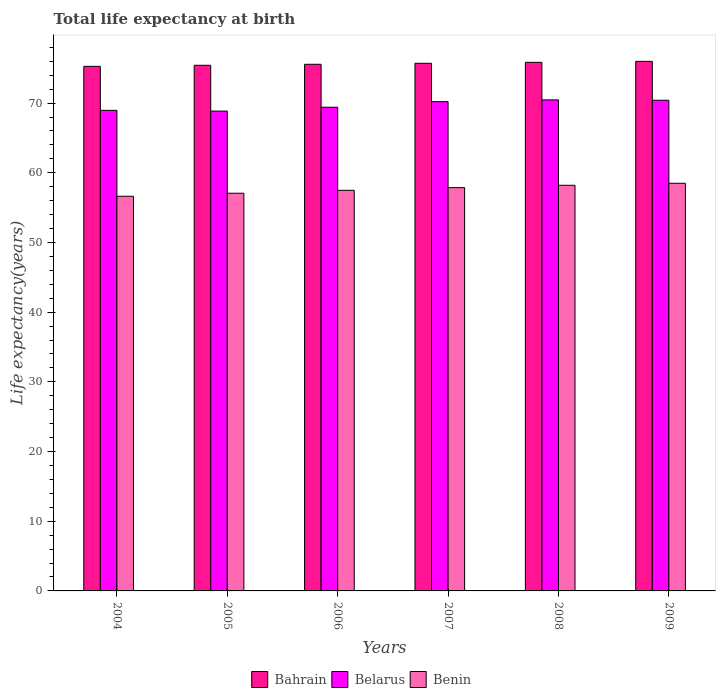How many groups of bars are there?
Your response must be concise. 6. Are the number of bars per tick equal to the number of legend labels?
Your answer should be very brief. Yes. How many bars are there on the 4th tick from the left?
Ensure brevity in your answer.  3. How many bars are there on the 3rd tick from the right?
Ensure brevity in your answer.  3. What is the life expectancy at birth in in Belarus in 2004?
Make the answer very short. 68.96. Across all years, what is the maximum life expectancy at birth in in Benin?
Provide a short and direct response. 58.49. Across all years, what is the minimum life expectancy at birth in in Benin?
Offer a very short reply. 56.63. In which year was the life expectancy at birth in in Benin maximum?
Your response must be concise. 2009. In which year was the life expectancy at birth in in Bahrain minimum?
Offer a terse response. 2004. What is the total life expectancy at birth in in Bahrain in the graph?
Ensure brevity in your answer.  453.8. What is the difference between the life expectancy at birth in in Bahrain in 2008 and that in 2009?
Provide a succinct answer. -0.14. What is the difference between the life expectancy at birth in in Belarus in 2007 and the life expectancy at birth in in Benin in 2009?
Ensure brevity in your answer.  11.71. What is the average life expectancy at birth in in Benin per year?
Offer a very short reply. 57.62. In the year 2005, what is the difference between the life expectancy at birth in in Belarus and life expectancy at birth in in Benin?
Your response must be concise. 11.79. In how many years, is the life expectancy at birth in in Benin greater than 2 years?
Offer a very short reply. 6. What is the ratio of the life expectancy at birth in in Bahrain in 2004 to that in 2007?
Ensure brevity in your answer.  0.99. Is the life expectancy at birth in in Bahrain in 2007 less than that in 2008?
Your response must be concise. Yes. What is the difference between the highest and the second highest life expectancy at birth in in Bahrain?
Keep it short and to the point. 0.14. What is the difference between the highest and the lowest life expectancy at birth in in Benin?
Provide a short and direct response. 1.86. In how many years, is the life expectancy at birth in in Benin greater than the average life expectancy at birth in in Benin taken over all years?
Ensure brevity in your answer.  3. What does the 3rd bar from the left in 2004 represents?
Ensure brevity in your answer.  Benin. What does the 1st bar from the right in 2008 represents?
Offer a terse response. Benin. Does the graph contain grids?
Make the answer very short. No. Where does the legend appear in the graph?
Keep it short and to the point. Bottom center. How many legend labels are there?
Make the answer very short. 3. What is the title of the graph?
Offer a very short reply. Total life expectancy at birth. What is the label or title of the Y-axis?
Your response must be concise. Life expectancy(years). What is the Life expectancy(years) of Bahrain in 2004?
Ensure brevity in your answer.  75.27. What is the Life expectancy(years) of Belarus in 2004?
Provide a succinct answer. 68.96. What is the Life expectancy(years) in Benin in 2004?
Your answer should be very brief. 56.63. What is the Life expectancy(years) in Bahrain in 2005?
Keep it short and to the point. 75.42. What is the Life expectancy(years) of Belarus in 2005?
Keep it short and to the point. 68.85. What is the Life expectancy(years) of Benin in 2005?
Provide a short and direct response. 57.07. What is the Life expectancy(years) of Bahrain in 2006?
Provide a short and direct response. 75.57. What is the Life expectancy(years) in Belarus in 2006?
Offer a very short reply. 69.4. What is the Life expectancy(years) in Benin in 2006?
Provide a short and direct response. 57.48. What is the Life expectancy(years) of Bahrain in 2007?
Your response must be concise. 75.71. What is the Life expectancy(years) of Belarus in 2007?
Your answer should be compact. 70.2. What is the Life expectancy(years) in Benin in 2007?
Your answer should be compact. 57.87. What is the Life expectancy(years) in Bahrain in 2008?
Your answer should be compact. 75.85. What is the Life expectancy(years) of Belarus in 2008?
Provide a succinct answer. 70.46. What is the Life expectancy(years) of Benin in 2008?
Offer a very short reply. 58.2. What is the Life expectancy(years) of Bahrain in 2009?
Provide a short and direct response. 75.99. What is the Life expectancy(years) in Belarus in 2009?
Your answer should be very brief. 70.41. What is the Life expectancy(years) in Benin in 2009?
Your answer should be very brief. 58.49. Across all years, what is the maximum Life expectancy(years) of Bahrain?
Ensure brevity in your answer.  75.99. Across all years, what is the maximum Life expectancy(years) of Belarus?
Give a very brief answer. 70.46. Across all years, what is the maximum Life expectancy(years) in Benin?
Give a very brief answer. 58.49. Across all years, what is the minimum Life expectancy(years) in Bahrain?
Keep it short and to the point. 75.27. Across all years, what is the minimum Life expectancy(years) in Belarus?
Your answer should be very brief. 68.85. Across all years, what is the minimum Life expectancy(years) in Benin?
Your response must be concise. 56.63. What is the total Life expectancy(years) of Bahrain in the graph?
Your answer should be compact. 453.8. What is the total Life expectancy(years) in Belarus in the graph?
Offer a terse response. 418.28. What is the total Life expectancy(years) in Benin in the graph?
Offer a terse response. 345.75. What is the difference between the Life expectancy(years) of Bahrain in 2004 and that in 2005?
Your answer should be compact. -0.15. What is the difference between the Life expectancy(years) of Belarus in 2004 and that in 2005?
Keep it short and to the point. 0.1. What is the difference between the Life expectancy(years) in Benin in 2004 and that in 2005?
Your answer should be very brief. -0.43. What is the difference between the Life expectancy(years) of Bahrain in 2004 and that in 2006?
Provide a short and direct response. -0.29. What is the difference between the Life expectancy(years) of Belarus in 2004 and that in 2006?
Provide a succinct answer. -0.45. What is the difference between the Life expectancy(years) of Benin in 2004 and that in 2006?
Offer a terse response. -0.85. What is the difference between the Life expectancy(years) of Bahrain in 2004 and that in 2007?
Your answer should be very brief. -0.43. What is the difference between the Life expectancy(years) in Belarus in 2004 and that in 2007?
Ensure brevity in your answer.  -1.25. What is the difference between the Life expectancy(years) of Benin in 2004 and that in 2007?
Offer a terse response. -1.23. What is the difference between the Life expectancy(years) in Bahrain in 2004 and that in 2008?
Your answer should be very brief. -0.57. What is the difference between the Life expectancy(years) in Benin in 2004 and that in 2008?
Offer a very short reply. -1.57. What is the difference between the Life expectancy(years) of Bahrain in 2004 and that in 2009?
Your answer should be very brief. -0.71. What is the difference between the Life expectancy(years) of Belarus in 2004 and that in 2009?
Ensure brevity in your answer.  -1.45. What is the difference between the Life expectancy(years) in Benin in 2004 and that in 2009?
Provide a succinct answer. -1.86. What is the difference between the Life expectancy(years) of Bahrain in 2005 and that in 2006?
Offer a terse response. -0.14. What is the difference between the Life expectancy(years) of Belarus in 2005 and that in 2006?
Offer a very short reply. -0.55. What is the difference between the Life expectancy(years) of Benin in 2005 and that in 2006?
Your answer should be very brief. -0.42. What is the difference between the Life expectancy(years) in Bahrain in 2005 and that in 2007?
Give a very brief answer. -0.29. What is the difference between the Life expectancy(years) in Belarus in 2005 and that in 2007?
Offer a terse response. -1.35. What is the difference between the Life expectancy(years) of Benin in 2005 and that in 2007?
Your answer should be very brief. -0.8. What is the difference between the Life expectancy(years) of Bahrain in 2005 and that in 2008?
Your answer should be compact. -0.43. What is the difference between the Life expectancy(years) in Belarus in 2005 and that in 2008?
Offer a very short reply. -1.6. What is the difference between the Life expectancy(years) in Benin in 2005 and that in 2008?
Your answer should be very brief. -1.14. What is the difference between the Life expectancy(years) of Bahrain in 2005 and that in 2009?
Your answer should be very brief. -0.57. What is the difference between the Life expectancy(years) in Belarus in 2005 and that in 2009?
Your response must be concise. -1.56. What is the difference between the Life expectancy(years) of Benin in 2005 and that in 2009?
Ensure brevity in your answer.  -1.43. What is the difference between the Life expectancy(years) in Bahrain in 2006 and that in 2007?
Keep it short and to the point. -0.14. What is the difference between the Life expectancy(years) in Belarus in 2006 and that in 2007?
Provide a short and direct response. -0.8. What is the difference between the Life expectancy(years) of Benin in 2006 and that in 2007?
Ensure brevity in your answer.  -0.38. What is the difference between the Life expectancy(years) of Bahrain in 2006 and that in 2008?
Provide a short and direct response. -0.28. What is the difference between the Life expectancy(years) in Belarus in 2006 and that in 2008?
Offer a terse response. -1.05. What is the difference between the Life expectancy(years) of Benin in 2006 and that in 2008?
Your response must be concise. -0.72. What is the difference between the Life expectancy(years) in Bahrain in 2006 and that in 2009?
Your answer should be very brief. -0.42. What is the difference between the Life expectancy(years) in Belarus in 2006 and that in 2009?
Your response must be concise. -1. What is the difference between the Life expectancy(years) in Benin in 2006 and that in 2009?
Ensure brevity in your answer.  -1.01. What is the difference between the Life expectancy(years) in Bahrain in 2007 and that in 2008?
Offer a terse response. -0.14. What is the difference between the Life expectancy(years) in Belarus in 2007 and that in 2008?
Ensure brevity in your answer.  -0.25. What is the difference between the Life expectancy(years) in Benin in 2007 and that in 2008?
Your answer should be very brief. -0.34. What is the difference between the Life expectancy(years) of Bahrain in 2007 and that in 2009?
Offer a very short reply. -0.28. What is the difference between the Life expectancy(years) of Belarus in 2007 and that in 2009?
Provide a succinct answer. -0.2. What is the difference between the Life expectancy(years) in Benin in 2007 and that in 2009?
Keep it short and to the point. -0.62. What is the difference between the Life expectancy(years) in Bahrain in 2008 and that in 2009?
Your response must be concise. -0.14. What is the difference between the Life expectancy(years) in Belarus in 2008 and that in 2009?
Your answer should be compact. 0.05. What is the difference between the Life expectancy(years) in Benin in 2008 and that in 2009?
Keep it short and to the point. -0.29. What is the difference between the Life expectancy(years) of Bahrain in 2004 and the Life expectancy(years) of Belarus in 2005?
Offer a terse response. 6.42. What is the difference between the Life expectancy(years) in Bahrain in 2004 and the Life expectancy(years) in Benin in 2005?
Your answer should be compact. 18.21. What is the difference between the Life expectancy(years) in Belarus in 2004 and the Life expectancy(years) in Benin in 2005?
Provide a short and direct response. 11.89. What is the difference between the Life expectancy(years) in Bahrain in 2004 and the Life expectancy(years) in Belarus in 2006?
Make the answer very short. 5.87. What is the difference between the Life expectancy(years) of Bahrain in 2004 and the Life expectancy(years) of Benin in 2006?
Make the answer very short. 17.79. What is the difference between the Life expectancy(years) in Belarus in 2004 and the Life expectancy(years) in Benin in 2006?
Offer a very short reply. 11.47. What is the difference between the Life expectancy(years) in Bahrain in 2004 and the Life expectancy(years) in Belarus in 2007?
Provide a short and direct response. 5.07. What is the difference between the Life expectancy(years) of Bahrain in 2004 and the Life expectancy(years) of Benin in 2007?
Give a very brief answer. 17.41. What is the difference between the Life expectancy(years) of Belarus in 2004 and the Life expectancy(years) of Benin in 2007?
Provide a succinct answer. 11.09. What is the difference between the Life expectancy(years) of Bahrain in 2004 and the Life expectancy(years) of Belarus in 2008?
Give a very brief answer. 4.82. What is the difference between the Life expectancy(years) in Bahrain in 2004 and the Life expectancy(years) in Benin in 2008?
Give a very brief answer. 17.07. What is the difference between the Life expectancy(years) in Belarus in 2004 and the Life expectancy(years) in Benin in 2008?
Ensure brevity in your answer.  10.75. What is the difference between the Life expectancy(years) in Bahrain in 2004 and the Life expectancy(years) in Belarus in 2009?
Offer a terse response. 4.87. What is the difference between the Life expectancy(years) in Bahrain in 2004 and the Life expectancy(years) in Benin in 2009?
Give a very brief answer. 16.78. What is the difference between the Life expectancy(years) of Belarus in 2004 and the Life expectancy(years) of Benin in 2009?
Offer a terse response. 10.46. What is the difference between the Life expectancy(years) of Bahrain in 2005 and the Life expectancy(years) of Belarus in 2006?
Provide a short and direct response. 6.02. What is the difference between the Life expectancy(years) of Bahrain in 2005 and the Life expectancy(years) of Benin in 2006?
Your answer should be very brief. 17.94. What is the difference between the Life expectancy(years) of Belarus in 2005 and the Life expectancy(years) of Benin in 2006?
Your answer should be very brief. 11.37. What is the difference between the Life expectancy(years) in Bahrain in 2005 and the Life expectancy(years) in Belarus in 2007?
Provide a short and direct response. 5.22. What is the difference between the Life expectancy(years) in Bahrain in 2005 and the Life expectancy(years) in Benin in 2007?
Your answer should be very brief. 17.55. What is the difference between the Life expectancy(years) of Belarus in 2005 and the Life expectancy(years) of Benin in 2007?
Offer a terse response. 10.98. What is the difference between the Life expectancy(years) of Bahrain in 2005 and the Life expectancy(years) of Belarus in 2008?
Offer a very short reply. 4.97. What is the difference between the Life expectancy(years) in Bahrain in 2005 and the Life expectancy(years) in Benin in 2008?
Provide a short and direct response. 17.22. What is the difference between the Life expectancy(years) of Belarus in 2005 and the Life expectancy(years) of Benin in 2008?
Provide a succinct answer. 10.65. What is the difference between the Life expectancy(years) of Bahrain in 2005 and the Life expectancy(years) of Belarus in 2009?
Your answer should be very brief. 5.01. What is the difference between the Life expectancy(years) in Bahrain in 2005 and the Life expectancy(years) in Benin in 2009?
Provide a short and direct response. 16.93. What is the difference between the Life expectancy(years) of Belarus in 2005 and the Life expectancy(years) of Benin in 2009?
Give a very brief answer. 10.36. What is the difference between the Life expectancy(years) of Bahrain in 2006 and the Life expectancy(years) of Belarus in 2007?
Your answer should be compact. 5.36. What is the difference between the Life expectancy(years) in Bahrain in 2006 and the Life expectancy(years) in Benin in 2007?
Keep it short and to the point. 17.7. What is the difference between the Life expectancy(years) in Belarus in 2006 and the Life expectancy(years) in Benin in 2007?
Make the answer very short. 11.54. What is the difference between the Life expectancy(years) of Bahrain in 2006 and the Life expectancy(years) of Belarus in 2008?
Give a very brief answer. 5.11. What is the difference between the Life expectancy(years) in Bahrain in 2006 and the Life expectancy(years) in Benin in 2008?
Your response must be concise. 17.36. What is the difference between the Life expectancy(years) in Belarus in 2006 and the Life expectancy(years) in Benin in 2008?
Your answer should be very brief. 11.2. What is the difference between the Life expectancy(years) in Bahrain in 2006 and the Life expectancy(years) in Belarus in 2009?
Provide a short and direct response. 5.16. What is the difference between the Life expectancy(years) in Bahrain in 2006 and the Life expectancy(years) in Benin in 2009?
Your answer should be compact. 17.08. What is the difference between the Life expectancy(years) in Belarus in 2006 and the Life expectancy(years) in Benin in 2009?
Your answer should be very brief. 10.91. What is the difference between the Life expectancy(years) of Bahrain in 2007 and the Life expectancy(years) of Belarus in 2008?
Make the answer very short. 5.25. What is the difference between the Life expectancy(years) of Bahrain in 2007 and the Life expectancy(years) of Benin in 2008?
Offer a terse response. 17.5. What is the difference between the Life expectancy(years) of Belarus in 2007 and the Life expectancy(years) of Benin in 2008?
Provide a succinct answer. 12. What is the difference between the Life expectancy(years) of Bahrain in 2007 and the Life expectancy(years) of Belarus in 2009?
Your answer should be compact. 5.3. What is the difference between the Life expectancy(years) in Bahrain in 2007 and the Life expectancy(years) in Benin in 2009?
Give a very brief answer. 17.22. What is the difference between the Life expectancy(years) in Belarus in 2007 and the Life expectancy(years) in Benin in 2009?
Provide a short and direct response. 11.71. What is the difference between the Life expectancy(years) of Bahrain in 2008 and the Life expectancy(years) of Belarus in 2009?
Offer a very short reply. 5.44. What is the difference between the Life expectancy(years) in Bahrain in 2008 and the Life expectancy(years) in Benin in 2009?
Ensure brevity in your answer.  17.36. What is the difference between the Life expectancy(years) of Belarus in 2008 and the Life expectancy(years) of Benin in 2009?
Ensure brevity in your answer.  11.96. What is the average Life expectancy(years) in Bahrain per year?
Give a very brief answer. 75.63. What is the average Life expectancy(years) in Belarus per year?
Your response must be concise. 69.71. What is the average Life expectancy(years) of Benin per year?
Keep it short and to the point. 57.62. In the year 2004, what is the difference between the Life expectancy(years) of Bahrain and Life expectancy(years) of Belarus?
Give a very brief answer. 6.32. In the year 2004, what is the difference between the Life expectancy(years) of Bahrain and Life expectancy(years) of Benin?
Make the answer very short. 18.64. In the year 2004, what is the difference between the Life expectancy(years) of Belarus and Life expectancy(years) of Benin?
Provide a succinct answer. 12.32. In the year 2005, what is the difference between the Life expectancy(years) in Bahrain and Life expectancy(years) in Belarus?
Provide a succinct answer. 6.57. In the year 2005, what is the difference between the Life expectancy(years) in Bahrain and Life expectancy(years) in Benin?
Ensure brevity in your answer.  18.36. In the year 2005, what is the difference between the Life expectancy(years) of Belarus and Life expectancy(years) of Benin?
Make the answer very short. 11.79. In the year 2006, what is the difference between the Life expectancy(years) of Bahrain and Life expectancy(years) of Belarus?
Make the answer very short. 6.16. In the year 2006, what is the difference between the Life expectancy(years) in Bahrain and Life expectancy(years) in Benin?
Ensure brevity in your answer.  18.08. In the year 2006, what is the difference between the Life expectancy(years) of Belarus and Life expectancy(years) of Benin?
Ensure brevity in your answer.  11.92. In the year 2007, what is the difference between the Life expectancy(years) in Bahrain and Life expectancy(years) in Belarus?
Your response must be concise. 5.5. In the year 2007, what is the difference between the Life expectancy(years) in Bahrain and Life expectancy(years) in Benin?
Keep it short and to the point. 17.84. In the year 2007, what is the difference between the Life expectancy(years) of Belarus and Life expectancy(years) of Benin?
Make the answer very short. 12.34. In the year 2008, what is the difference between the Life expectancy(years) of Bahrain and Life expectancy(years) of Belarus?
Give a very brief answer. 5.39. In the year 2008, what is the difference between the Life expectancy(years) of Bahrain and Life expectancy(years) of Benin?
Provide a short and direct response. 17.64. In the year 2008, what is the difference between the Life expectancy(years) in Belarus and Life expectancy(years) in Benin?
Keep it short and to the point. 12.25. In the year 2009, what is the difference between the Life expectancy(years) in Bahrain and Life expectancy(years) in Belarus?
Offer a terse response. 5.58. In the year 2009, what is the difference between the Life expectancy(years) in Bahrain and Life expectancy(years) in Benin?
Offer a very short reply. 17.5. In the year 2009, what is the difference between the Life expectancy(years) of Belarus and Life expectancy(years) of Benin?
Offer a terse response. 11.92. What is the ratio of the Life expectancy(years) of Bahrain in 2004 to that in 2005?
Keep it short and to the point. 1. What is the ratio of the Life expectancy(years) of Belarus in 2004 to that in 2005?
Offer a very short reply. 1. What is the ratio of the Life expectancy(years) in Benin in 2004 to that in 2005?
Your response must be concise. 0.99. What is the ratio of the Life expectancy(years) of Belarus in 2004 to that in 2006?
Make the answer very short. 0.99. What is the ratio of the Life expectancy(years) in Benin in 2004 to that in 2006?
Offer a very short reply. 0.99. What is the ratio of the Life expectancy(years) of Bahrain in 2004 to that in 2007?
Make the answer very short. 0.99. What is the ratio of the Life expectancy(years) of Belarus in 2004 to that in 2007?
Ensure brevity in your answer.  0.98. What is the ratio of the Life expectancy(years) in Benin in 2004 to that in 2007?
Your answer should be compact. 0.98. What is the ratio of the Life expectancy(years) of Belarus in 2004 to that in 2008?
Your answer should be very brief. 0.98. What is the ratio of the Life expectancy(years) of Bahrain in 2004 to that in 2009?
Your answer should be very brief. 0.99. What is the ratio of the Life expectancy(years) of Belarus in 2004 to that in 2009?
Provide a succinct answer. 0.98. What is the ratio of the Life expectancy(years) of Benin in 2004 to that in 2009?
Offer a very short reply. 0.97. What is the ratio of the Life expectancy(years) in Bahrain in 2005 to that in 2006?
Offer a terse response. 1. What is the ratio of the Life expectancy(years) in Belarus in 2005 to that in 2007?
Provide a short and direct response. 0.98. What is the ratio of the Life expectancy(years) of Benin in 2005 to that in 2007?
Your response must be concise. 0.99. What is the ratio of the Life expectancy(years) in Bahrain in 2005 to that in 2008?
Offer a very short reply. 0.99. What is the ratio of the Life expectancy(years) in Belarus in 2005 to that in 2008?
Offer a terse response. 0.98. What is the ratio of the Life expectancy(years) of Benin in 2005 to that in 2008?
Give a very brief answer. 0.98. What is the ratio of the Life expectancy(years) of Belarus in 2005 to that in 2009?
Your answer should be compact. 0.98. What is the ratio of the Life expectancy(years) of Benin in 2005 to that in 2009?
Your response must be concise. 0.98. What is the ratio of the Life expectancy(years) of Bahrain in 2006 to that in 2007?
Your answer should be compact. 1. What is the ratio of the Life expectancy(years) of Benin in 2006 to that in 2007?
Offer a terse response. 0.99. What is the ratio of the Life expectancy(years) in Bahrain in 2006 to that in 2008?
Ensure brevity in your answer.  1. What is the ratio of the Life expectancy(years) of Belarus in 2006 to that in 2008?
Offer a very short reply. 0.99. What is the ratio of the Life expectancy(years) of Benin in 2006 to that in 2008?
Keep it short and to the point. 0.99. What is the ratio of the Life expectancy(years) of Belarus in 2006 to that in 2009?
Your answer should be compact. 0.99. What is the ratio of the Life expectancy(years) of Benin in 2006 to that in 2009?
Your answer should be very brief. 0.98. What is the ratio of the Life expectancy(years) in Benin in 2007 to that in 2008?
Give a very brief answer. 0.99. What is the ratio of the Life expectancy(years) in Bahrain in 2007 to that in 2009?
Keep it short and to the point. 1. What is the ratio of the Life expectancy(years) of Belarus in 2007 to that in 2009?
Offer a terse response. 1. What is the ratio of the Life expectancy(years) of Benin in 2007 to that in 2009?
Provide a short and direct response. 0.99. What is the difference between the highest and the second highest Life expectancy(years) of Bahrain?
Your answer should be very brief. 0.14. What is the difference between the highest and the second highest Life expectancy(years) in Belarus?
Offer a very short reply. 0.05. What is the difference between the highest and the second highest Life expectancy(years) in Benin?
Offer a very short reply. 0.29. What is the difference between the highest and the lowest Life expectancy(years) in Bahrain?
Your answer should be compact. 0.71. What is the difference between the highest and the lowest Life expectancy(years) in Belarus?
Ensure brevity in your answer.  1.6. What is the difference between the highest and the lowest Life expectancy(years) of Benin?
Give a very brief answer. 1.86. 